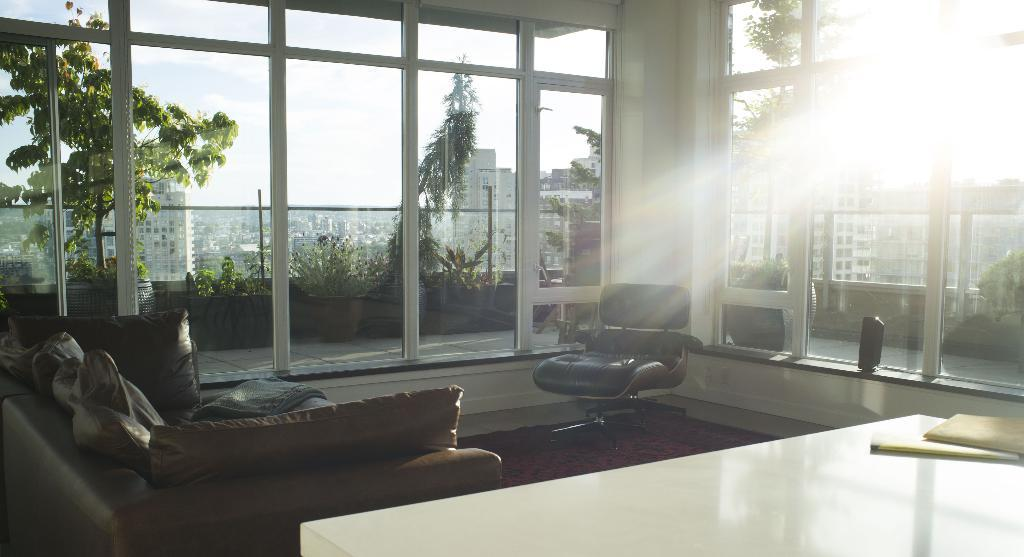What type of space is depicted in the image? There is a room in the image. What furniture is present in the room? There is a sofa with pillows and a chair in the room. What is on the table in the room? There is a stick and a book on the table. What can be seen through the window in the room? Buildings, trees, and flower pots are visible through the window. What type of cable is connected to the rabbit in the image? There is no rabbit present in the image, so there is no cable connected to it. 